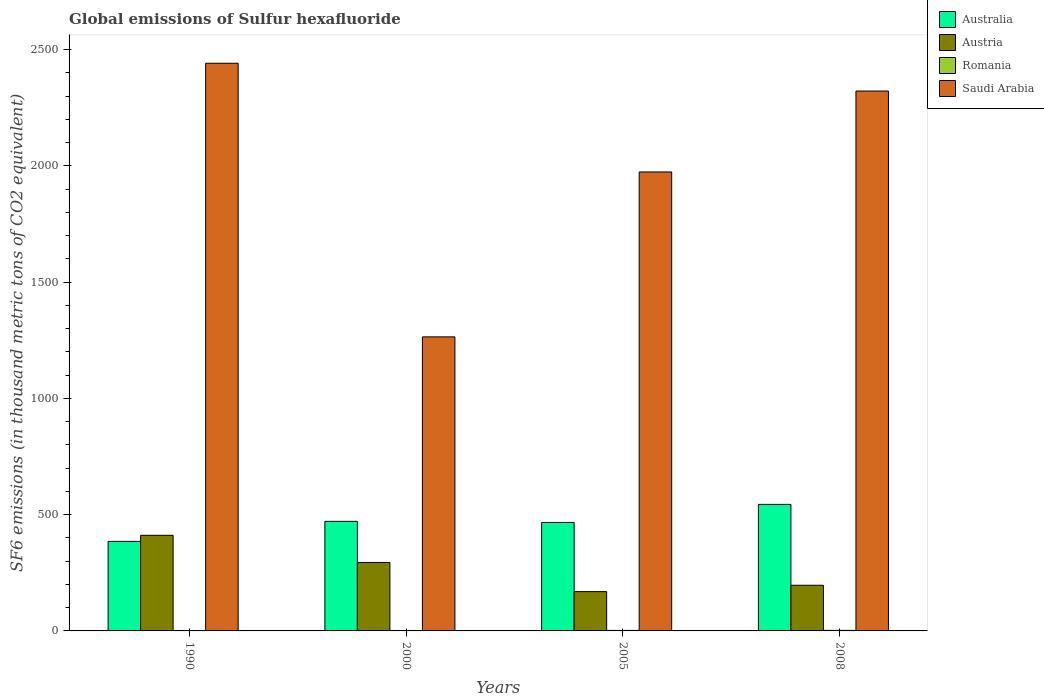How many different coloured bars are there?
Keep it short and to the point. 4. Are the number of bars per tick equal to the number of legend labels?
Your answer should be very brief. Yes. Are the number of bars on each tick of the X-axis equal?
Offer a terse response. Yes. How many bars are there on the 1st tick from the right?
Provide a short and direct response. 4. What is the global emissions of Sulfur hexafluoride in Romania in 2008?
Make the answer very short. 2.3. Across all years, what is the maximum global emissions of Sulfur hexafluoride in Saudi Arabia?
Offer a terse response. 2441.3. In which year was the global emissions of Sulfur hexafluoride in Australia maximum?
Provide a short and direct response. 2008. In which year was the global emissions of Sulfur hexafluoride in Romania minimum?
Give a very brief answer. 1990. What is the total global emissions of Sulfur hexafluoride in Saudi Arabia in the graph?
Give a very brief answer. 8001.5. What is the difference between the global emissions of Sulfur hexafluoride in Saudi Arabia in 1990 and that in 2005?
Your answer should be compact. 467.5. What is the difference between the global emissions of Sulfur hexafluoride in Australia in 2008 and the global emissions of Sulfur hexafluoride in Romania in 1990?
Keep it short and to the point. 542.5. What is the average global emissions of Sulfur hexafluoride in Saudi Arabia per year?
Your answer should be compact. 2000.38. In the year 2008, what is the difference between the global emissions of Sulfur hexafluoride in Romania and global emissions of Sulfur hexafluoride in Australia?
Your answer should be very brief. -541.8. Is the difference between the global emissions of Sulfur hexafluoride in Romania in 2000 and 2008 greater than the difference between the global emissions of Sulfur hexafluoride in Australia in 2000 and 2008?
Your answer should be compact. Yes. What is the difference between the highest and the second highest global emissions of Sulfur hexafluoride in Saudi Arabia?
Ensure brevity in your answer.  119.5. What is the difference between the highest and the lowest global emissions of Sulfur hexafluoride in Romania?
Your answer should be compact. 0.7. Is the sum of the global emissions of Sulfur hexafluoride in Australia in 2005 and 2008 greater than the maximum global emissions of Sulfur hexafluoride in Romania across all years?
Offer a terse response. Yes. Is it the case that in every year, the sum of the global emissions of Sulfur hexafluoride in Austria and global emissions of Sulfur hexafluoride in Romania is greater than the sum of global emissions of Sulfur hexafluoride in Australia and global emissions of Sulfur hexafluoride in Saudi Arabia?
Provide a succinct answer. No. What does the 1st bar from the right in 2008 represents?
Offer a very short reply. Saudi Arabia. Are all the bars in the graph horizontal?
Make the answer very short. No. How many years are there in the graph?
Your answer should be compact. 4. What is the difference between two consecutive major ticks on the Y-axis?
Your answer should be compact. 500. Does the graph contain grids?
Make the answer very short. No. How are the legend labels stacked?
Keep it short and to the point. Vertical. What is the title of the graph?
Your answer should be very brief. Global emissions of Sulfur hexafluoride. Does "Yemen, Rep." appear as one of the legend labels in the graph?
Provide a succinct answer. No. What is the label or title of the Y-axis?
Provide a short and direct response. SF6 emissions (in thousand metric tons of CO2 equivalent). What is the SF6 emissions (in thousand metric tons of CO2 equivalent) of Australia in 1990?
Provide a succinct answer. 385.1. What is the SF6 emissions (in thousand metric tons of CO2 equivalent) in Austria in 1990?
Give a very brief answer. 411.2. What is the SF6 emissions (in thousand metric tons of CO2 equivalent) of Romania in 1990?
Offer a terse response. 1.6. What is the SF6 emissions (in thousand metric tons of CO2 equivalent) of Saudi Arabia in 1990?
Offer a terse response. 2441.3. What is the SF6 emissions (in thousand metric tons of CO2 equivalent) in Australia in 2000?
Your answer should be compact. 471.2. What is the SF6 emissions (in thousand metric tons of CO2 equivalent) in Austria in 2000?
Give a very brief answer. 294.4. What is the SF6 emissions (in thousand metric tons of CO2 equivalent) in Romania in 2000?
Keep it short and to the point. 2. What is the SF6 emissions (in thousand metric tons of CO2 equivalent) in Saudi Arabia in 2000?
Give a very brief answer. 1264.6. What is the SF6 emissions (in thousand metric tons of CO2 equivalent) of Australia in 2005?
Your response must be concise. 466.6. What is the SF6 emissions (in thousand metric tons of CO2 equivalent) in Austria in 2005?
Your answer should be very brief. 169. What is the SF6 emissions (in thousand metric tons of CO2 equivalent) of Saudi Arabia in 2005?
Keep it short and to the point. 1973.8. What is the SF6 emissions (in thousand metric tons of CO2 equivalent) in Australia in 2008?
Your answer should be very brief. 544.1. What is the SF6 emissions (in thousand metric tons of CO2 equivalent) of Austria in 2008?
Provide a short and direct response. 196.4. What is the SF6 emissions (in thousand metric tons of CO2 equivalent) in Saudi Arabia in 2008?
Ensure brevity in your answer.  2321.8. Across all years, what is the maximum SF6 emissions (in thousand metric tons of CO2 equivalent) of Australia?
Provide a succinct answer. 544.1. Across all years, what is the maximum SF6 emissions (in thousand metric tons of CO2 equivalent) of Austria?
Your answer should be compact. 411.2. Across all years, what is the maximum SF6 emissions (in thousand metric tons of CO2 equivalent) of Saudi Arabia?
Provide a short and direct response. 2441.3. Across all years, what is the minimum SF6 emissions (in thousand metric tons of CO2 equivalent) in Australia?
Offer a terse response. 385.1. Across all years, what is the minimum SF6 emissions (in thousand metric tons of CO2 equivalent) in Austria?
Ensure brevity in your answer.  169. Across all years, what is the minimum SF6 emissions (in thousand metric tons of CO2 equivalent) of Saudi Arabia?
Offer a terse response. 1264.6. What is the total SF6 emissions (in thousand metric tons of CO2 equivalent) in Australia in the graph?
Offer a terse response. 1867. What is the total SF6 emissions (in thousand metric tons of CO2 equivalent) in Austria in the graph?
Keep it short and to the point. 1071. What is the total SF6 emissions (in thousand metric tons of CO2 equivalent) of Romania in the graph?
Make the answer very short. 8.1. What is the total SF6 emissions (in thousand metric tons of CO2 equivalent) of Saudi Arabia in the graph?
Keep it short and to the point. 8001.5. What is the difference between the SF6 emissions (in thousand metric tons of CO2 equivalent) of Australia in 1990 and that in 2000?
Offer a very short reply. -86.1. What is the difference between the SF6 emissions (in thousand metric tons of CO2 equivalent) in Austria in 1990 and that in 2000?
Your response must be concise. 116.8. What is the difference between the SF6 emissions (in thousand metric tons of CO2 equivalent) of Romania in 1990 and that in 2000?
Your answer should be compact. -0.4. What is the difference between the SF6 emissions (in thousand metric tons of CO2 equivalent) in Saudi Arabia in 1990 and that in 2000?
Offer a very short reply. 1176.7. What is the difference between the SF6 emissions (in thousand metric tons of CO2 equivalent) in Australia in 1990 and that in 2005?
Offer a terse response. -81.5. What is the difference between the SF6 emissions (in thousand metric tons of CO2 equivalent) of Austria in 1990 and that in 2005?
Provide a succinct answer. 242.2. What is the difference between the SF6 emissions (in thousand metric tons of CO2 equivalent) of Saudi Arabia in 1990 and that in 2005?
Your answer should be compact. 467.5. What is the difference between the SF6 emissions (in thousand metric tons of CO2 equivalent) of Australia in 1990 and that in 2008?
Provide a short and direct response. -159. What is the difference between the SF6 emissions (in thousand metric tons of CO2 equivalent) in Austria in 1990 and that in 2008?
Ensure brevity in your answer.  214.8. What is the difference between the SF6 emissions (in thousand metric tons of CO2 equivalent) of Saudi Arabia in 1990 and that in 2008?
Keep it short and to the point. 119.5. What is the difference between the SF6 emissions (in thousand metric tons of CO2 equivalent) of Austria in 2000 and that in 2005?
Give a very brief answer. 125.4. What is the difference between the SF6 emissions (in thousand metric tons of CO2 equivalent) in Saudi Arabia in 2000 and that in 2005?
Make the answer very short. -709.2. What is the difference between the SF6 emissions (in thousand metric tons of CO2 equivalent) in Australia in 2000 and that in 2008?
Your response must be concise. -72.9. What is the difference between the SF6 emissions (in thousand metric tons of CO2 equivalent) of Romania in 2000 and that in 2008?
Provide a succinct answer. -0.3. What is the difference between the SF6 emissions (in thousand metric tons of CO2 equivalent) of Saudi Arabia in 2000 and that in 2008?
Offer a terse response. -1057.2. What is the difference between the SF6 emissions (in thousand metric tons of CO2 equivalent) in Australia in 2005 and that in 2008?
Offer a terse response. -77.5. What is the difference between the SF6 emissions (in thousand metric tons of CO2 equivalent) of Austria in 2005 and that in 2008?
Your response must be concise. -27.4. What is the difference between the SF6 emissions (in thousand metric tons of CO2 equivalent) in Saudi Arabia in 2005 and that in 2008?
Offer a terse response. -348. What is the difference between the SF6 emissions (in thousand metric tons of CO2 equivalent) in Australia in 1990 and the SF6 emissions (in thousand metric tons of CO2 equivalent) in Austria in 2000?
Offer a very short reply. 90.7. What is the difference between the SF6 emissions (in thousand metric tons of CO2 equivalent) of Australia in 1990 and the SF6 emissions (in thousand metric tons of CO2 equivalent) of Romania in 2000?
Offer a very short reply. 383.1. What is the difference between the SF6 emissions (in thousand metric tons of CO2 equivalent) of Australia in 1990 and the SF6 emissions (in thousand metric tons of CO2 equivalent) of Saudi Arabia in 2000?
Keep it short and to the point. -879.5. What is the difference between the SF6 emissions (in thousand metric tons of CO2 equivalent) of Austria in 1990 and the SF6 emissions (in thousand metric tons of CO2 equivalent) of Romania in 2000?
Offer a very short reply. 409.2. What is the difference between the SF6 emissions (in thousand metric tons of CO2 equivalent) in Austria in 1990 and the SF6 emissions (in thousand metric tons of CO2 equivalent) in Saudi Arabia in 2000?
Offer a very short reply. -853.4. What is the difference between the SF6 emissions (in thousand metric tons of CO2 equivalent) in Romania in 1990 and the SF6 emissions (in thousand metric tons of CO2 equivalent) in Saudi Arabia in 2000?
Give a very brief answer. -1263. What is the difference between the SF6 emissions (in thousand metric tons of CO2 equivalent) of Australia in 1990 and the SF6 emissions (in thousand metric tons of CO2 equivalent) of Austria in 2005?
Offer a terse response. 216.1. What is the difference between the SF6 emissions (in thousand metric tons of CO2 equivalent) in Australia in 1990 and the SF6 emissions (in thousand metric tons of CO2 equivalent) in Romania in 2005?
Make the answer very short. 382.9. What is the difference between the SF6 emissions (in thousand metric tons of CO2 equivalent) of Australia in 1990 and the SF6 emissions (in thousand metric tons of CO2 equivalent) of Saudi Arabia in 2005?
Offer a terse response. -1588.7. What is the difference between the SF6 emissions (in thousand metric tons of CO2 equivalent) in Austria in 1990 and the SF6 emissions (in thousand metric tons of CO2 equivalent) in Romania in 2005?
Your response must be concise. 409. What is the difference between the SF6 emissions (in thousand metric tons of CO2 equivalent) of Austria in 1990 and the SF6 emissions (in thousand metric tons of CO2 equivalent) of Saudi Arabia in 2005?
Your response must be concise. -1562.6. What is the difference between the SF6 emissions (in thousand metric tons of CO2 equivalent) in Romania in 1990 and the SF6 emissions (in thousand metric tons of CO2 equivalent) in Saudi Arabia in 2005?
Ensure brevity in your answer.  -1972.2. What is the difference between the SF6 emissions (in thousand metric tons of CO2 equivalent) of Australia in 1990 and the SF6 emissions (in thousand metric tons of CO2 equivalent) of Austria in 2008?
Your answer should be very brief. 188.7. What is the difference between the SF6 emissions (in thousand metric tons of CO2 equivalent) in Australia in 1990 and the SF6 emissions (in thousand metric tons of CO2 equivalent) in Romania in 2008?
Your response must be concise. 382.8. What is the difference between the SF6 emissions (in thousand metric tons of CO2 equivalent) in Australia in 1990 and the SF6 emissions (in thousand metric tons of CO2 equivalent) in Saudi Arabia in 2008?
Provide a succinct answer. -1936.7. What is the difference between the SF6 emissions (in thousand metric tons of CO2 equivalent) of Austria in 1990 and the SF6 emissions (in thousand metric tons of CO2 equivalent) of Romania in 2008?
Provide a succinct answer. 408.9. What is the difference between the SF6 emissions (in thousand metric tons of CO2 equivalent) in Austria in 1990 and the SF6 emissions (in thousand metric tons of CO2 equivalent) in Saudi Arabia in 2008?
Provide a short and direct response. -1910.6. What is the difference between the SF6 emissions (in thousand metric tons of CO2 equivalent) of Romania in 1990 and the SF6 emissions (in thousand metric tons of CO2 equivalent) of Saudi Arabia in 2008?
Keep it short and to the point. -2320.2. What is the difference between the SF6 emissions (in thousand metric tons of CO2 equivalent) of Australia in 2000 and the SF6 emissions (in thousand metric tons of CO2 equivalent) of Austria in 2005?
Provide a short and direct response. 302.2. What is the difference between the SF6 emissions (in thousand metric tons of CO2 equivalent) of Australia in 2000 and the SF6 emissions (in thousand metric tons of CO2 equivalent) of Romania in 2005?
Provide a succinct answer. 469. What is the difference between the SF6 emissions (in thousand metric tons of CO2 equivalent) of Australia in 2000 and the SF6 emissions (in thousand metric tons of CO2 equivalent) of Saudi Arabia in 2005?
Keep it short and to the point. -1502.6. What is the difference between the SF6 emissions (in thousand metric tons of CO2 equivalent) in Austria in 2000 and the SF6 emissions (in thousand metric tons of CO2 equivalent) in Romania in 2005?
Provide a succinct answer. 292.2. What is the difference between the SF6 emissions (in thousand metric tons of CO2 equivalent) in Austria in 2000 and the SF6 emissions (in thousand metric tons of CO2 equivalent) in Saudi Arabia in 2005?
Your answer should be very brief. -1679.4. What is the difference between the SF6 emissions (in thousand metric tons of CO2 equivalent) in Romania in 2000 and the SF6 emissions (in thousand metric tons of CO2 equivalent) in Saudi Arabia in 2005?
Make the answer very short. -1971.8. What is the difference between the SF6 emissions (in thousand metric tons of CO2 equivalent) of Australia in 2000 and the SF6 emissions (in thousand metric tons of CO2 equivalent) of Austria in 2008?
Your answer should be very brief. 274.8. What is the difference between the SF6 emissions (in thousand metric tons of CO2 equivalent) in Australia in 2000 and the SF6 emissions (in thousand metric tons of CO2 equivalent) in Romania in 2008?
Offer a terse response. 468.9. What is the difference between the SF6 emissions (in thousand metric tons of CO2 equivalent) of Australia in 2000 and the SF6 emissions (in thousand metric tons of CO2 equivalent) of Saudi Arabia in 2008?
Keep it short and to the point. -1850.6. What is the difference between the SF6 emissions (in thousand metric tons of CO2 equivalent) of Austria in 2000 and the SF6 emissions (in thousand metric tons of CO2 equivalent) of Romania in 2008?
Offer a very short reply. 292.1. What is the difference between the SF6 emissions (in thousand metric tons of CO2 equivalent) of Austria in 2000 and the SF6 emissions (in thousand metric tons of CO2 equivalent) of Saudi Arabia in 2008?
Your answer should be very brief. -2027.4. What is the difference between the SF6 emissions (in thousand metric tons of CO2 equivalent) of Romania in 2000 and the SF6 emissions (in thousand metric tons of CO2 equivalent) of Saudi Arabia in 2008?
Provide a succinct answer. -2319.8. What is the difference between the SF6 emissions (in thousand metric tons of CO2 equivalent) in Australia in 2005 and the SF6 emissions (in thousand metric tons of CO2 equivalent) in Austria in 2008?
Make the answer very short. 270.2. What is the difference between the SF6 emissions (in thousand metric tons of CO2 equivalent) of Australia in 2005 and the SF6 emissions (in thousand metric tons of CO2 equivalent) of Romania in 2008?
Your response must be concise. 464.3. What is the difference between the SF6 emissions (in thousand metric tons of CO2 equivalent) of Australia in 2005 and the SF6 emissions (in thousand metric tons of CO2 equivalent) of Saudi Arabia in 2008?
Your answer should be very brief. -1855.2. What is the difference between the SF6 emissions (in thousand metric tons of CO2 equivalent) of Austria in 2005 and the SF6 emissions (in thousand metric tons of CO2 equivalent) of Romania in 2008?
Ensure brevity in your answer.  166.7. What is the difference between the SF6 emissions (in thousand metric tons of CO2 equivalent) in Austria in 2005 and the SF6 emissions (in thousand metric tons of CO2 equivalent) in Saudi Arabia in 2008?
Your answer should be very brief. -2152.8. What is the difference between the SF6 emissions (in thousand metric tons of CO2 equivalent) in Romania in 2005 and the SF6 emissions (in thousand metric tons of CO2 equivalent) in Saudi Arabia in 2008?
Give a very brief answer. -2319.6. What is the average SF6 emissions (in thousand metric tons of CO2 equivalent) of Australia per year?
Your response must be concise. 466.75. What is the average SF6 emissions (in thousand metric tons of CO2 equivalent) in Austria per year?
Offer a very short reply. 267.75. What is the average SF6 emissions (in thousand metric tons of CO2 equivalent) of Romania per year?
Ensure brevity in your answer.  2.02. What is the average SF6 emissions (in thousand metric tons of CO2 equivalent) of Saudi Arabia per year?
Keep it short and to the point. 2000.38. In the year 1990, what is the difference between the SF6 emissions (in thousand metric tons of CO2 equivalent) of Australia and SF6 emissions (in thousand metric tons of CO2 equivalent) of Austria?
Provide a short and direct response. -26.1. In the year 1990, what is the difference between the SF6 emissions (in thousand metric tons of CO2 equivalent) of Australia and SF6 emissions (in thousand metric tons of CO2 equivalent) of Romania?
Make the answer very short. 383.5. In the year 1990, what is the difference between the SF6 emissions (in thousand metric tons of CO2 equivalent) of Australia and SF6 emissions (in thousand metric tons of CO2 equivalent) of Saudi Arabia?
Ensure brevity in your answer.  -2056.2. In the year 1990, what is the difference between the SF6 emissions (in thousand metric tons of CO2 equivalent) in Austria and SF6 emissions (in thousand metric tons of CO2 equivalent) in Romania?
Make the answer very short. 409.6. In the year 1990, what is the difference between the SF6 emissions (in thousand metric tons of CO2 equivalent) of Austria and SF6 emissions (in thousand metric tons of CO2 equivalent) of Saudi Arabia?
Provide a short and direct response. -2030.1. In the year 1990, what is the difference between the SF6 emissions (in thousand metric tons of CO2 equivalent) of Romania and SF6 emissions (in thousand metric tons of CO2 equivalent) of Saudi Arabia?
Offer a very short reply. -2439.7. In the year 2000, what is the difference between the SF6 emissions (in thousand metric tons of CO2 equivalent) of Australia and SF6 emissions (in thousand metric tons of CO2 equivalent) of Austria?
Ensure brevity in your answer.  176.8. In the year 2000, what is the difference between the SF6 emissions (in thousand metric tons of CO2 equivalent) in Australia and SF6 emissions (in thousand metric tons of CO2 equivalent) in Romania?
Give a very brief answer. 469.2. In the year 2000, what is the difference between the SF6 emissions (in thousand metric tons of CO2 equivalent) in Australia and SF6 emissions (in thousand metric tons of CO2 equivalent) in Saudi Arabia?
Your answer should be very brief. -793.4. In the year 2000, what is the difference between the SF6 emissions (in thousand metric tons of CO2 equivalent) of Austria and SF6 emissions (in thousand metric tons of CO2 equivalent) of Romania?
Your response must be concise. 292.4. In the year 2000, what is the difference between the SF6 emissions (in thousand metric tons of CO2 equivalent) of Austria and SF6 emissions (in thousand metric tons of CO2 equivalent) of Saudi Arabia?
Ensure brevity in your answer.  -970.2. In the year 2000, what is the difference between the SF6 emissions (in thousand metric tons of CO2 equivalent) in Romania and SF6 emissions (in thousand metric tons of CO2 equivalent) in Saudi Arabia?
Your answer should be very brief. -1262.6. In the year 2005, what is the difference between the SF6 emissions (in thousand metric tons of CO2 equivalent) in Australia and SF6 emissions (in thousand metric tons of CO2 equivalent) in Austria?
Provide a succinct answer. 297.6. In the year 2005, what is the difference between the SF6 emissions (in thousand metric tons of CO2 equivalent) in Australia and SF6 emissions (in thousand metric tons of CO2 equivalent) in Romania?
Provide a short and direct response. 464.4. In the year 2005, what is the difference between the SF6 emissions (in thousand metric tons of CO2 equivalent) of Australia and SF6 emissions (in thousand metric tons of CO2 equivalent) of Saudi Arabia?
Provide a short and direct response. -1507.2. In the year 2005, what is the difference between the SF6 emissions (in thousand metric tons of CO2 equivalent) in Austria and SF6 emissions (in thousand metric tons of CO2 equivalent) in Romania?
Make the answer very short. 166.8. In the year 2005, what is the difference between the SF6 emissions (in thousand metric tons of CO2 equivalent) in Austria and SF6 emissions (in thousand metric tons of CO2 equivalent) in Saudi Arabia?
Make the answer very short. -1804.8. In the year 2005, what is the difference between the SF6 emissions (in thousand metric tons of CO2 equivalent) in Romania and SF6 emissions (in thousand metric tons of CO2 equivalent) in Saudi Arabia?
Your response must be concise. -1971.6. In the year 2008, what is the difference between the SF6 emissions (in thousand metric tons of CO2 equivalent) of Australia and SF6 emissions (in thousand metric tons of CO2 equivalent) of Austria?
Offer a very short reply. 347.7. In the year 2008, what is the difference between the SF6 emissions (in thousand metric tons of CO2 equivalent) of Australia and SF6 emissions (in thousand metric tons of CO2 equivalent) of Romania?
Your answer should be very brief. 541.8. In the year 2008, what is the difference between the SF6 emissions (in thousand metric tons of CO2 equivalent) in Australia and SF6 emissions (in thousand metric tons of CO2 equivalent) in Saudi Arabia?
Your answer should be compact. -1777.7. In the year 2008, what is the difference between the SF6 emissions (in thousand metric tons of CO2 equivalent) in Austria and SF6 emissions (in thousand metric tons of CO2 equivalent) in Romania?
Give a very brief answer. 194.1. In the year 2008, what is the difference between the SF6 emissions (in thousand metric tons of CO2 equivalent) in Austria and SF6 emissions (in thousand metric tons of CO2 equivalent) in Saudi Arabia?
Offer a very short reply. -2125.4. In the year 2008, what is the difference between the SF6 emissions (in thousand metric tons of CO2 equivalent) of Romania and SF6 emissions (in thousand metric tons of CO2 equivalent) of Saudi Arabia?
Give a very brief answer. -2319.5. What is the ratio of the SF6 emissions (in thousand metric tons of CO2 equivalent) of Australia in 1990 to that in 2000?
Offer a terse response. 0.82. What is the ratio of the SF6 emissions (in thousand metric tons of CO2 equivalent) of Austria in 1990 to that in 2000?
Provide a succinct answer. 1.4. What is the ratio of the SF6 emissions (in thousand metric tons of CO2 equivalent) in Saudi Arabia in 1990 to that in 2000?
Provide a succinct answer. 1.93. What is the ratio of the SF6 emissions (in thousand metric tons of CO2 equivalent) of Australia in 1990 to that in 2005?
Your answer should be very brief. 0.83. What is the ratio of the SF6 emissions (in thousand metric tons of CO2 equivalent) in Austria in 1990 to that in 2005?
Give a very brief answer. 2.43. What is the ratio of the SF6 emissions (in thousand metric tons of CO2 equivalent) in Romania in 1990 to that in 2005?
Provide a succinct answer. 0.73. What is the ratio of the SF6 emissions (in thousand metric tons of CO2 equivalent) of Saudi Arabia in 1990 to that in 2005?
Your answer should be compact. 1.24. What is the ratio of the SF6 emissions (in thousand metric tons of CO2 equivalent) in Australia in 1990 to that in 2008?
Offer a very short reply. 0.71. What is the ratio of the SF6 emissions (in thousand metric tons of CO2 equivalent) of Austria in 1990 to that in 2008?
Offer a terse response. 2.09. What is the ratio of the SF6 emissions (in thousand metric tons of CO2 equivalent) in Romania in 1990 to that in 2008?
Your answer should be compact. 0.7. What is the ratio of the SF6 emissions (in thousand metric tons of CO2 equivalent) of Saudi Arabia in 1990 to that in 2008?
Provide a short and direct response. 1.05. What is the ratio of the SF6 emissions (in thousand metric tons of CO2 equivalent) of Australia in 2000 to that in 2005?
Ensure brevity in your answer.  1.01. What is the ratio of the SF6 emissions (in thousand metric tons of CO2 equivalent) in Austria in 2000 to that in 2005?
Offer a terse response. 1.74. What is the ratio of the SF6 emissions (in thousand metric tons of CO2 equivalent) of Saudi Arabia in 2000 to that in 2005?
Give a very brief answer. 0.64. What is the ratio of the SF6 emissions (in thousand metric tons of CO2 equivalent) of Australia in 2000 to that in 2008?
Provide a short and direct response. 0.87. What is the ratio of the SF6 emissions (in thousand metric tons of CO2 equivalent) of Austria in 2000 to that in 2008?
Give a very brief answer. 1.5. What is the ratio of the SF6 emissions (in thousand metric tons of CO2 equivalent) in Romania in 2000 to that in 2008?
Offer a terse response. 0.87. What is the ratio of the SF6 emissions (in thousand metric tons of CO2 equivalent) of Saudi Arabia in 2000 to that in 2008?
Provide a succinct answer. 0.54. What is the ratio of the SF6 emissions (in thousand metric tons of CO2 equivalent) in Australia in 2005 to that in 2008?
Your answer should be compact. 0.86. What is the ratio of the SF6 emissions (in thousand metric tons of CO2 equivalent) in Austria in 2005 to that in 2008?
Provide a short and direct response. 0.86. What is the ratio of the SF6 emissions (in thousand metric tons of CO2 equivalent) of Romania in 2005 to that in 2008?
Make the answer very short. 0.96. What is the ratio of the SF6 emissions (in thousand metric tons of CO2 equivalent) in Saudi Arabia in 2005 to that in 2008?
Keep it short and to the point. 0.85. What is the difference between the highest and the second highest SF6 emissions (in thousand metric tons of CO2 equivalent) of Australia?
Make the answer very short. 72.9. What is the difference between the highest and the second highest SF6 emissions (in thousand metric tons of CO2 equivalent) in Austria?
Offer a terse response. 116.8. What is the difference between the highest and the second highest SF6 emissions (in thousand metric tons of CO2 equivalent) in Saudi Arabia?
Ensure brevity in your answer.  119.5. What is the difference between the highest and the lowest SF6 emissions (in thousand metric tons of CO2 equivalent) in Australia?
Keep it short and to the point. 159. What is the difference between the highest and the lowest SF6 emissions (in thousand metric tons of CO2 equivalent) of Austria?
Provide a short and direct response. 242.2. What is the difference between the highest and the lowest SF6 emissions (in thousand metric tons of CO2 equivalent) of Romania?
Provide a short and direct response. 0.7. What is the difference between the highest and the lowest SF6 emissions (in thousand metric tons of CO2 equivalent) of Saudi Arabia?
Provide a short and direct response. 1176.7. 